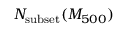Convert formula to latex. <formula><loc_0><loc_0><loc_500><loc_500>N _ { s u b s e t } ( M _ { 5 0 0 } )</formula> 